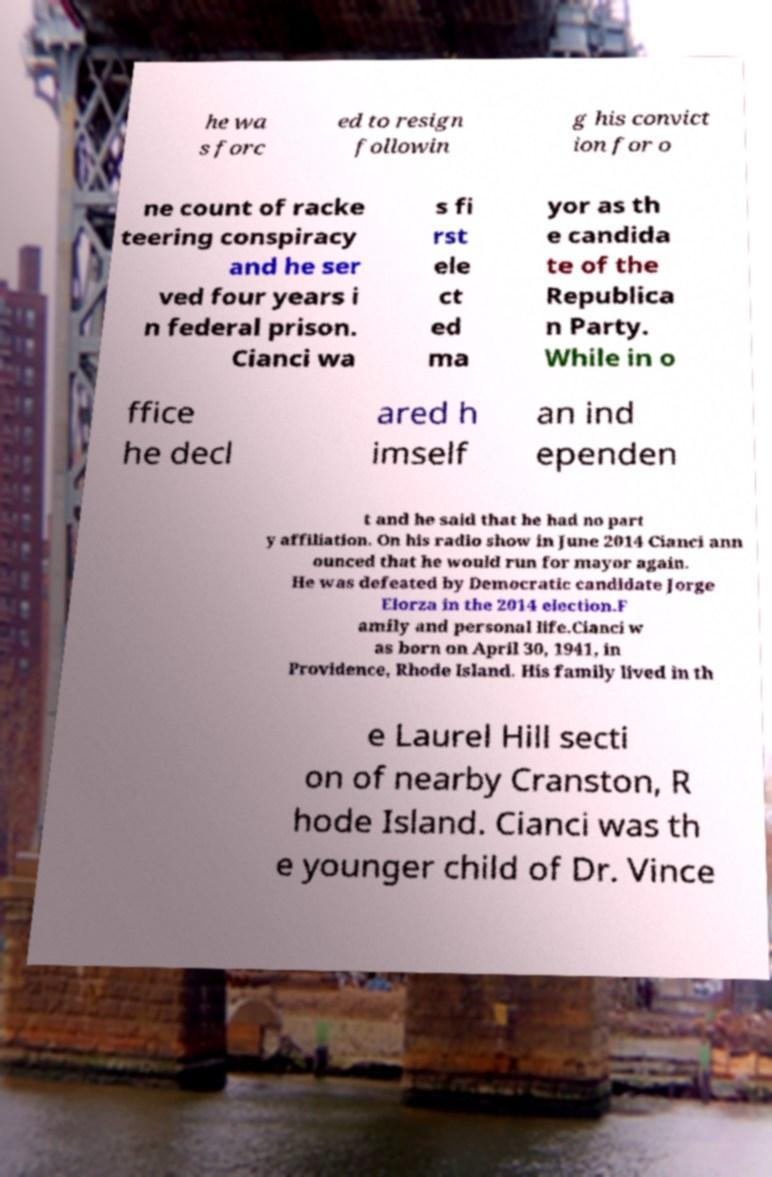Could you extract and type out the text from this image? he wa s forc ed to resign followin g his convict ion for o ne count of racke teering conspiracy and he ser ved four years i n federal prison. Cianci wa s fi rst ele ct ed ma yor as th e candida te of the Republica n Party. While in o ffice he decl ared h imself an ind ependen t and he said that he had no part y affiliation. On his radio show in June 2014 Cianci ann ounced that he would run for mayor again. He was defeated by Democratic candidate Jorge Elorza in the 2014 election.F amily and personal life.Cianci w as born on April 30, 1941, in Providence, Rhode Island. His family lived in th e Laurel Hill secti on of nearby Cranston, R hode Island. Cianci was th e younger child of Dr. Vince 